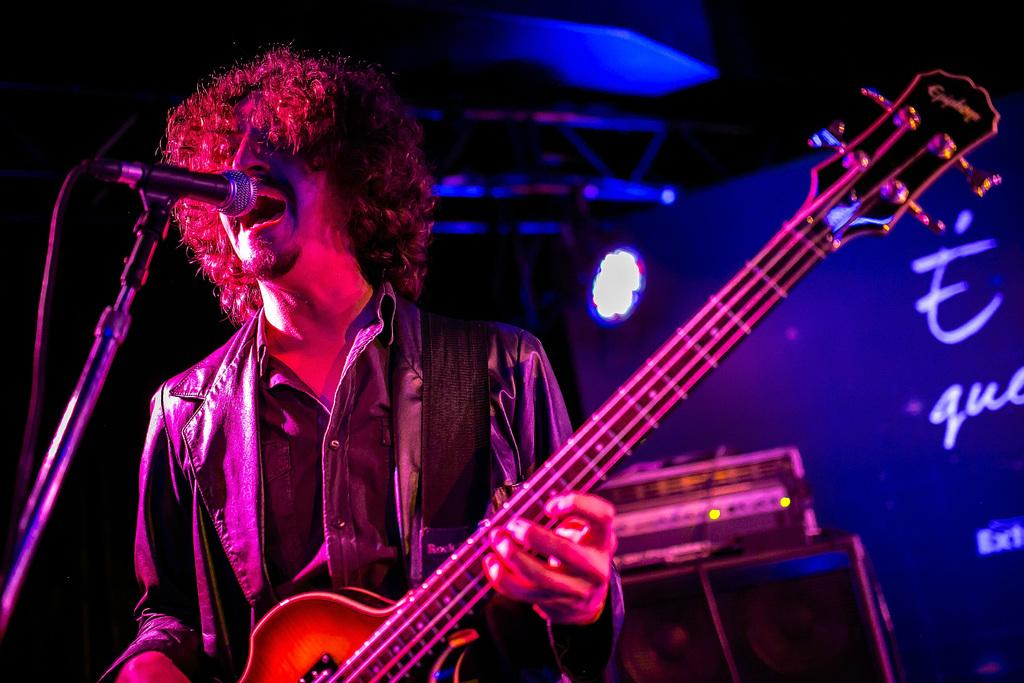What is the person in the image holding? The person is holding a guitar in the image. What object is present for amplifying sound? There is a microphone in the image. What can be seen in the background of the image? There is a banner in the background of the image. How many legs does the person's uncle have in the image? There is no uncle present in the image, and therefore no legs to count. What type of van can be seen parked near the person in the image? There is no van present in the image. 